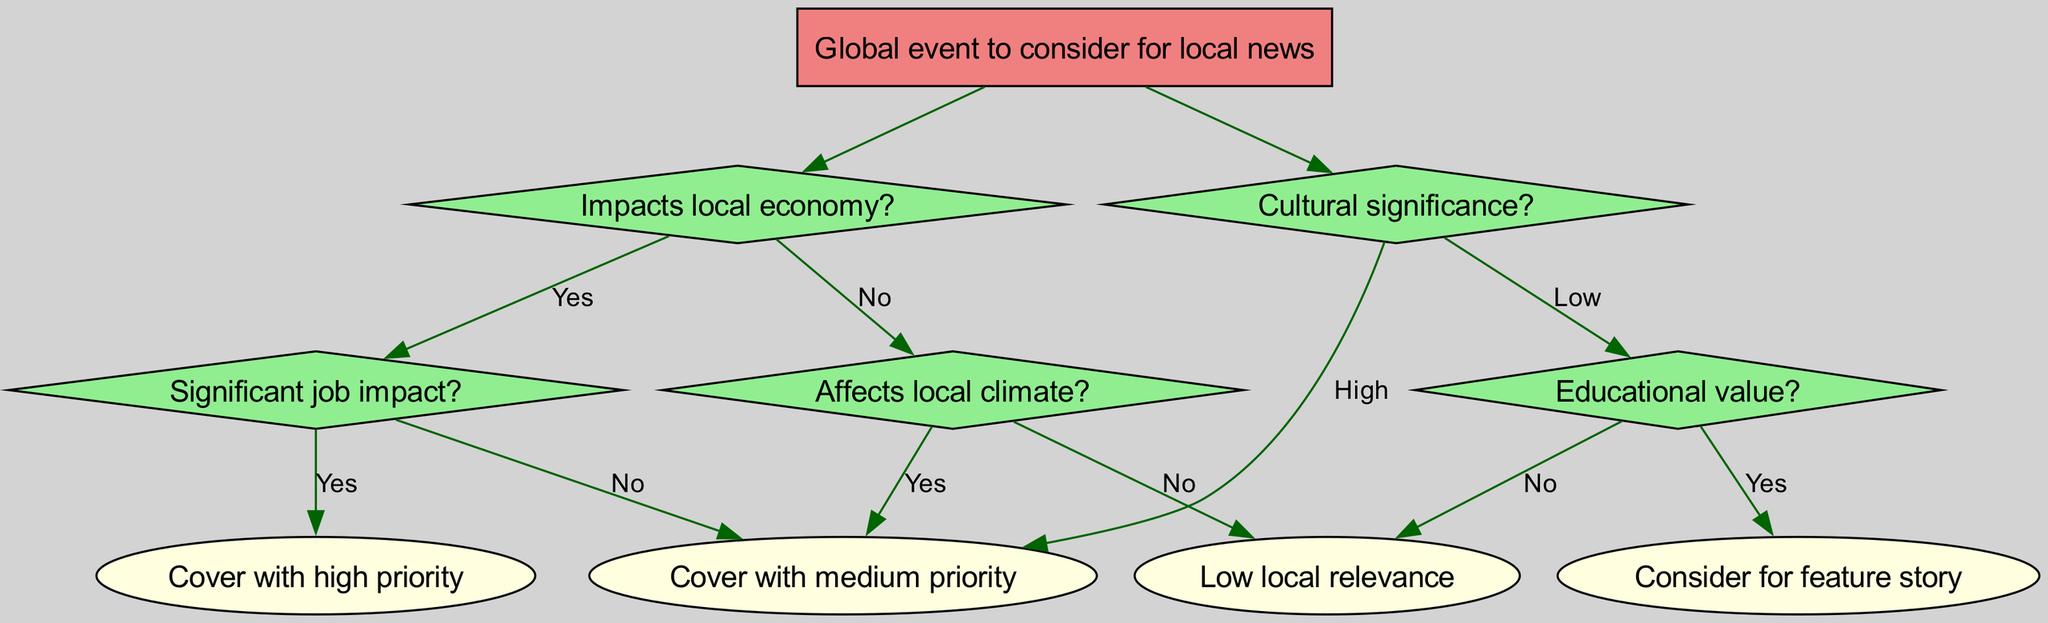What is the root node of the decision tree? The root node, which represents the starting point of the decision-making process, is stated directly at the top of the diagram. It is labeled as "Global event to consider for local news".
Answer: Global event to consider for local news How many main branches does the decision tree have? The diagram outlines two main branches that stem from the root node: one focuses on the local economy impacts and the other on cultural significance. Thus, we simply count them.
Answer: 2 What follows after the node "Impacts local economy?" if the answer is "Yes"? In the decision tree, if the answer to "Impacts local economy?" is "Yes", it moves to the next node, which asks about "Significant job impact?". This is a direct branch stemming from that decision point.
Answer: Significant job impact? What is the priority level for covering a global event that affects the local climate but not the local economy? If an event does not impact the local economy (answering "No" to the first branch) but does affect local climate (answering "Yes" to the related branch), the priority level for coverage is specified as "Cover with medium priority".
Answer: Cover with medium priority If the cultural significance is assessed as low and the educational value is also deemed "No", what is the next step? Starting from the "Cultural significance?" node, if assessed as low, it moves to the "Educational value?" node. If this too is assessed as “No”, the next and final step indicates "Low local relevance”. Therefore, this concludes the decision path based on the conditions set.
Answer: Low local relevance What action is suggested if an event has high cultural significance? In the decision tree, any event assessed to have high cultural significance leads directly to the indicator "Cover with medium priority". This path is solely dependent on that classification.
Answer: Cover with medium priority How do we proceed if an event impacts the local economy but does not have a significant job impact? If there is an impact on the local economy ("Yes" to that question), but the assessment of job significance is "No", according to the tree, the next action would be to "Cover with medium priority". This means that local relevance is acknowledged.
Answer: Cover with medium priority What is the relationship between "Impacts local economy?" and "Cultural significance?" The two nodes represent separate evaluation criteria. "Impacts local economy?" is a primary question branching directly from the root, while "Cultural significance?" is another branch evaluated independently. Hence, they are distinct paths in the decision-making process and do not influence each other directly.
Answer: Independent branches 